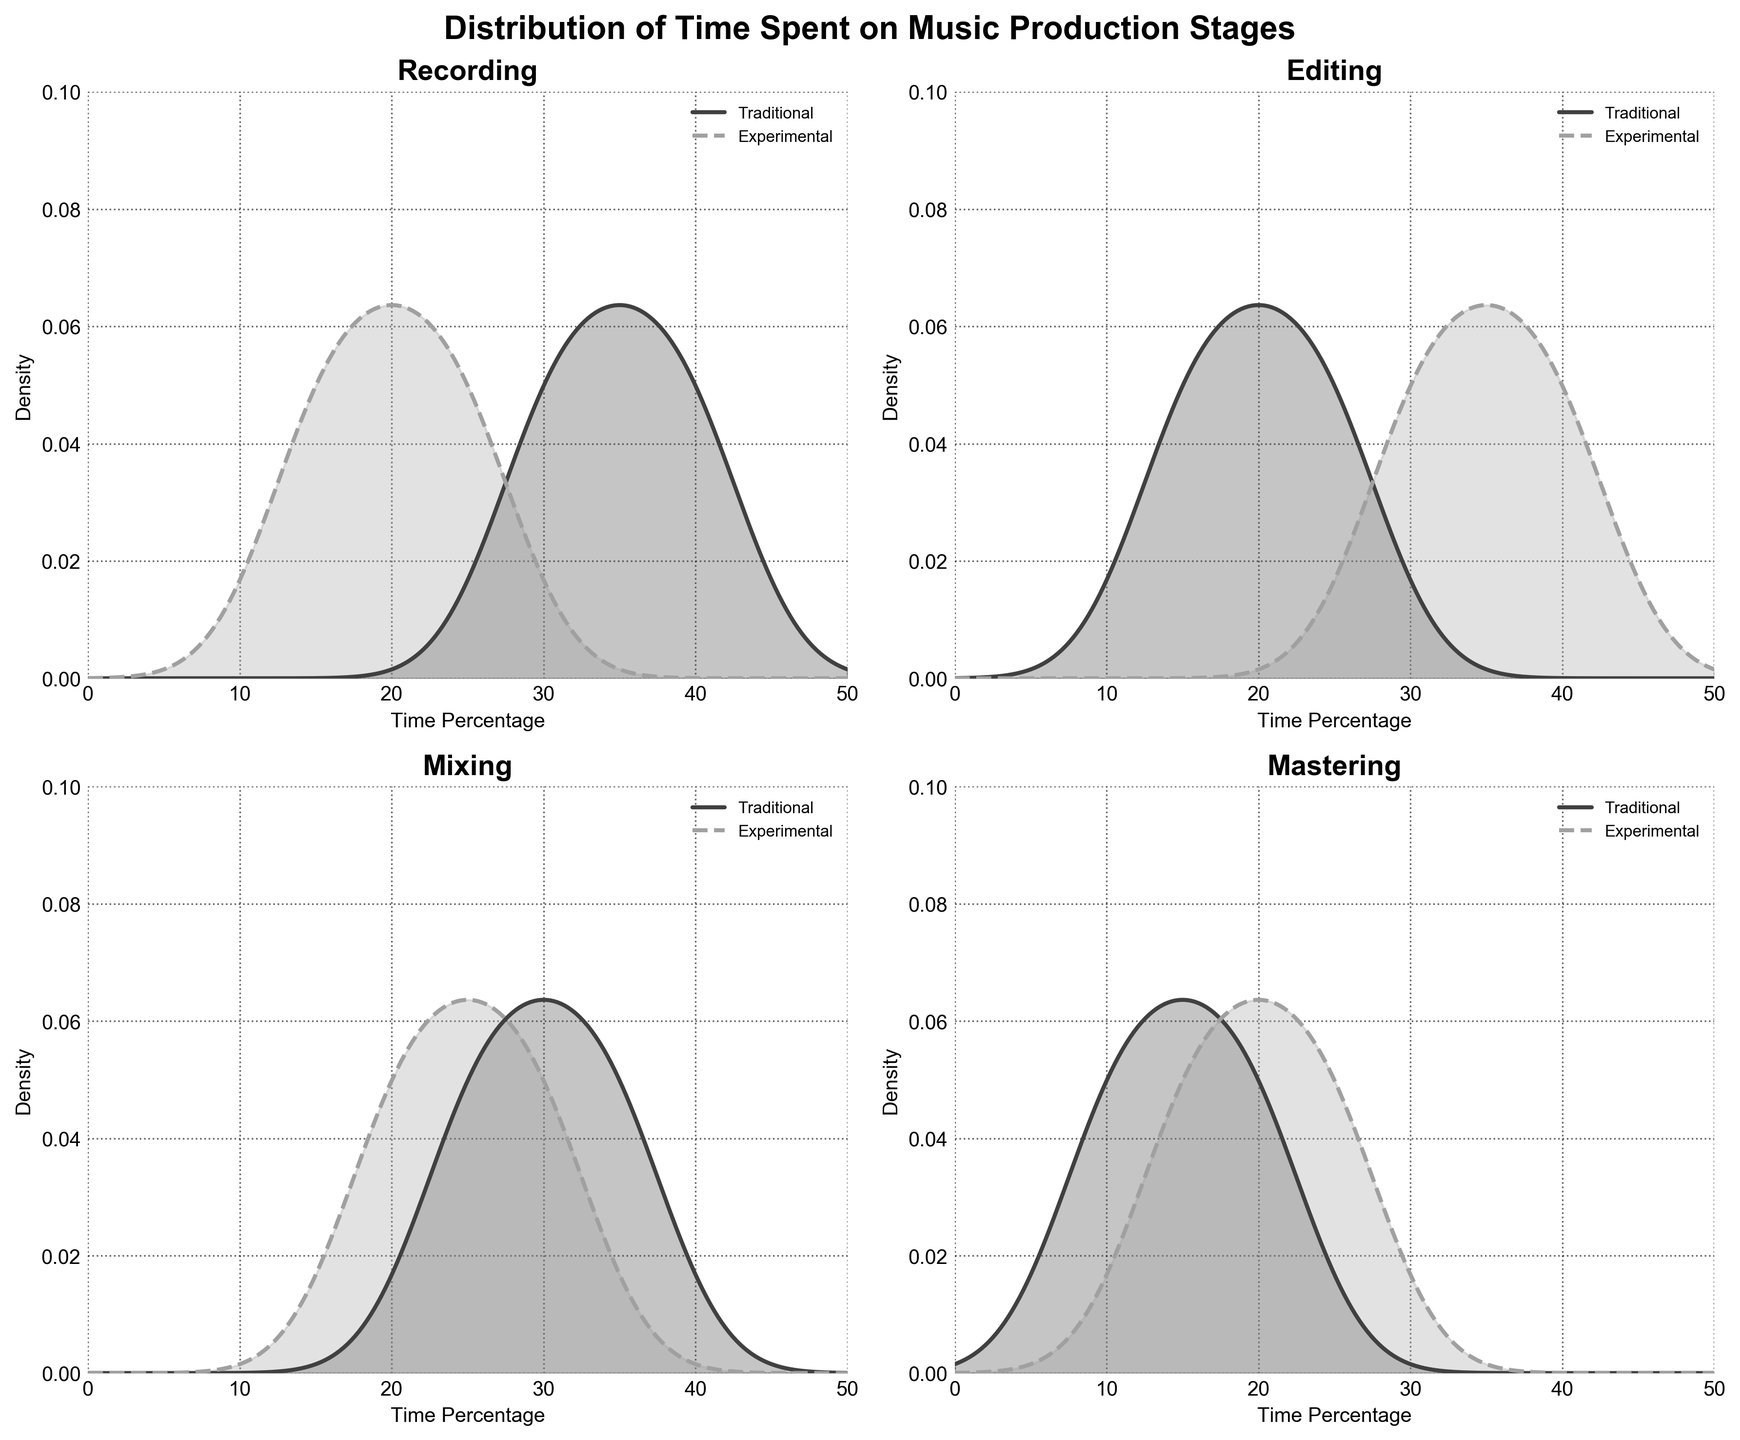What's the title of the figure? The title is located at the top center of the figure. It reads, "Distribution of Time Spent on Music Production Stages".
Answer: Distribution of Time Spent on Music Production Stages What is the y-axis measuring? The y-axis measures the density of time percentages for each stage of music production. This is indicated by the label "Density" on the y-axis of each subplot.
Answer: Density Which approach seems to spend more time on Recording on average? By observing the peaks of the density curves for the "Recording" stage, the Traditional approach has a peak at a higher time percentage compared to the Experimental approach.
Answer: Traditional How does the time spent on Editing compare between the two approaches? Both density curves for the Editing stage show a significant peak, but the Experimental approach shows a higher percentage of time spent, around 30-40%, while the Traditional approach peaks around 20-25%.
Answer: Experimental spends more time Which approach shows more variability in time spent on Mixing? The density plots for the Mixing stage show that the Experimental approach has a wider spread, indicating more variability in the time spent compared to the Traditional approach, which shows a more concentrated peak.
Answer: Experimental Is there a significant difference in time spent on Mastering between the two approaches? The density plots for the Mastering stage show that both approaches have a relatively similar distribution with a slight preference for different percentages, but the density peaks do not show a large deviation.
Answer: No significant difference What is the range of time percentages shown on the x-axis? The x-axis range for time percentages in all subplots spans from 0 to 50. This is observed from the axis labels.
Answer: 0 to 50 Which stage has the most similar time distribution between Traditional and Experimental approaches? The "Mastering" stage shows the most similar distribution between the two approaches, as indicated by closely aligned density curves.
Answer: Mastering Which stage shows the widest disparity in time spent between the two approaches? The "Editing" stage shows the widest disparity, as the peaks of the density curves for Traditional and Experimental approaches are at significantly different time percentages.
Answer: Editing 